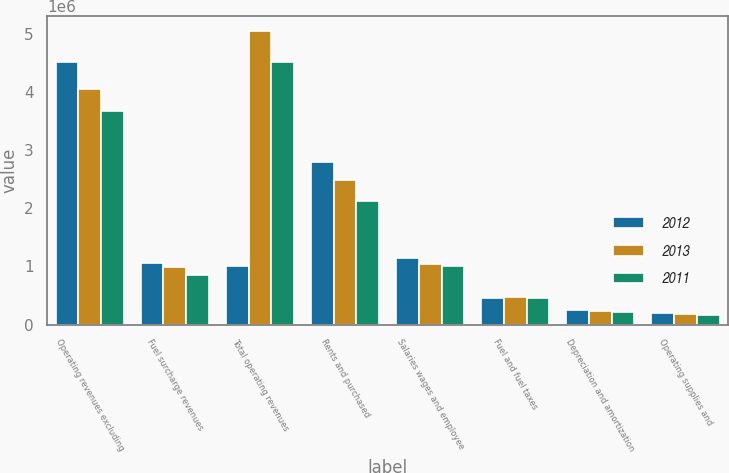<chart> <loc_0><loc_0><loc_500><loc_500><stacked_bar_chart><ecel><fcel>Operating revenues excluding<fcel>Fuel surcharge revenues<fcel>Total operating revenues<fcel>Rents and purchased<fcel>Salaries wages and employee<fcel>Fuel and fuel taxes<fcel>Depreciation and amortization<fcel>Operating supplies and<nl><fcel>2012<fcel>4.52724e+06<fcel>1.05733e+06<fcel>1.00195e+06<fcel>2.80557e+06<fcel>1.13821e+06<fcel>455926<fcel>253380<fcel>202700<nl><fcel>2013<fcel>4.05816e+06<fcel>996815<fcel>5.05498e+06<fcel>2.48564e+06<fcel>1.03753e+06<fcel>465874<fcel>229166<fcel>178610<nl><fcel>2011<fcel>3.67768e+06<fcel>849163<fcel>4.52684e+06<fcel>2.12281e+06<fcel>1.00195e+06<fcel>463597<fcel>213943<fcel>160425<nl></chart> 